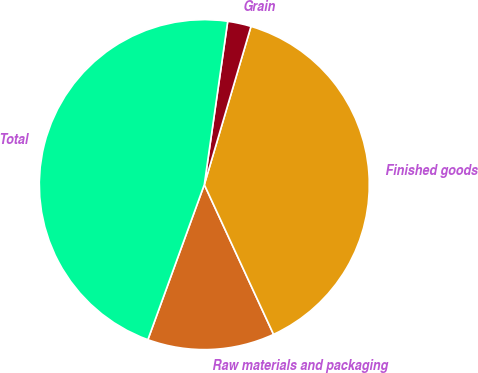Convert chart. <chart><loc_0><loc_0><loc_500><loc_500><pie_chart><fcel>Raw materials and packaging<fcel>Finished goods<fcel>Grain<fcel>Total<nl><fcel>12.45%<fcel>38.54%<fcel>2.3%<fcel>46.71%<nl></chart> 